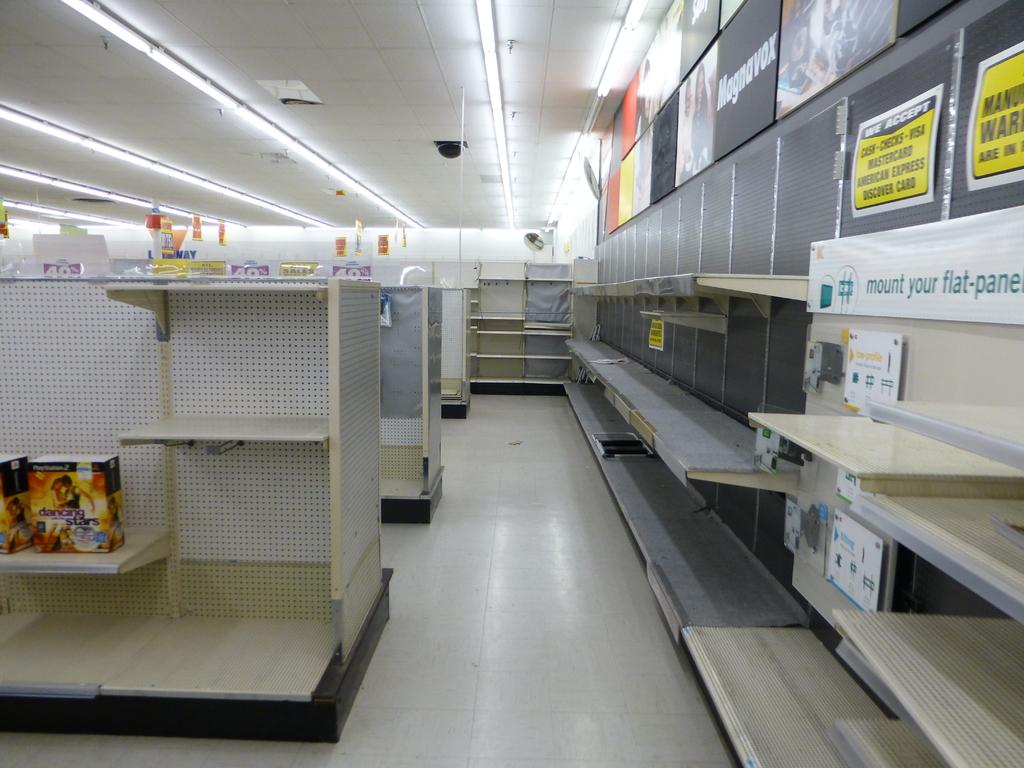<image>
Render a clear and concise summary of the photo. A store with a Dancing With the Stars PlayStation 2 box on a shelf. 